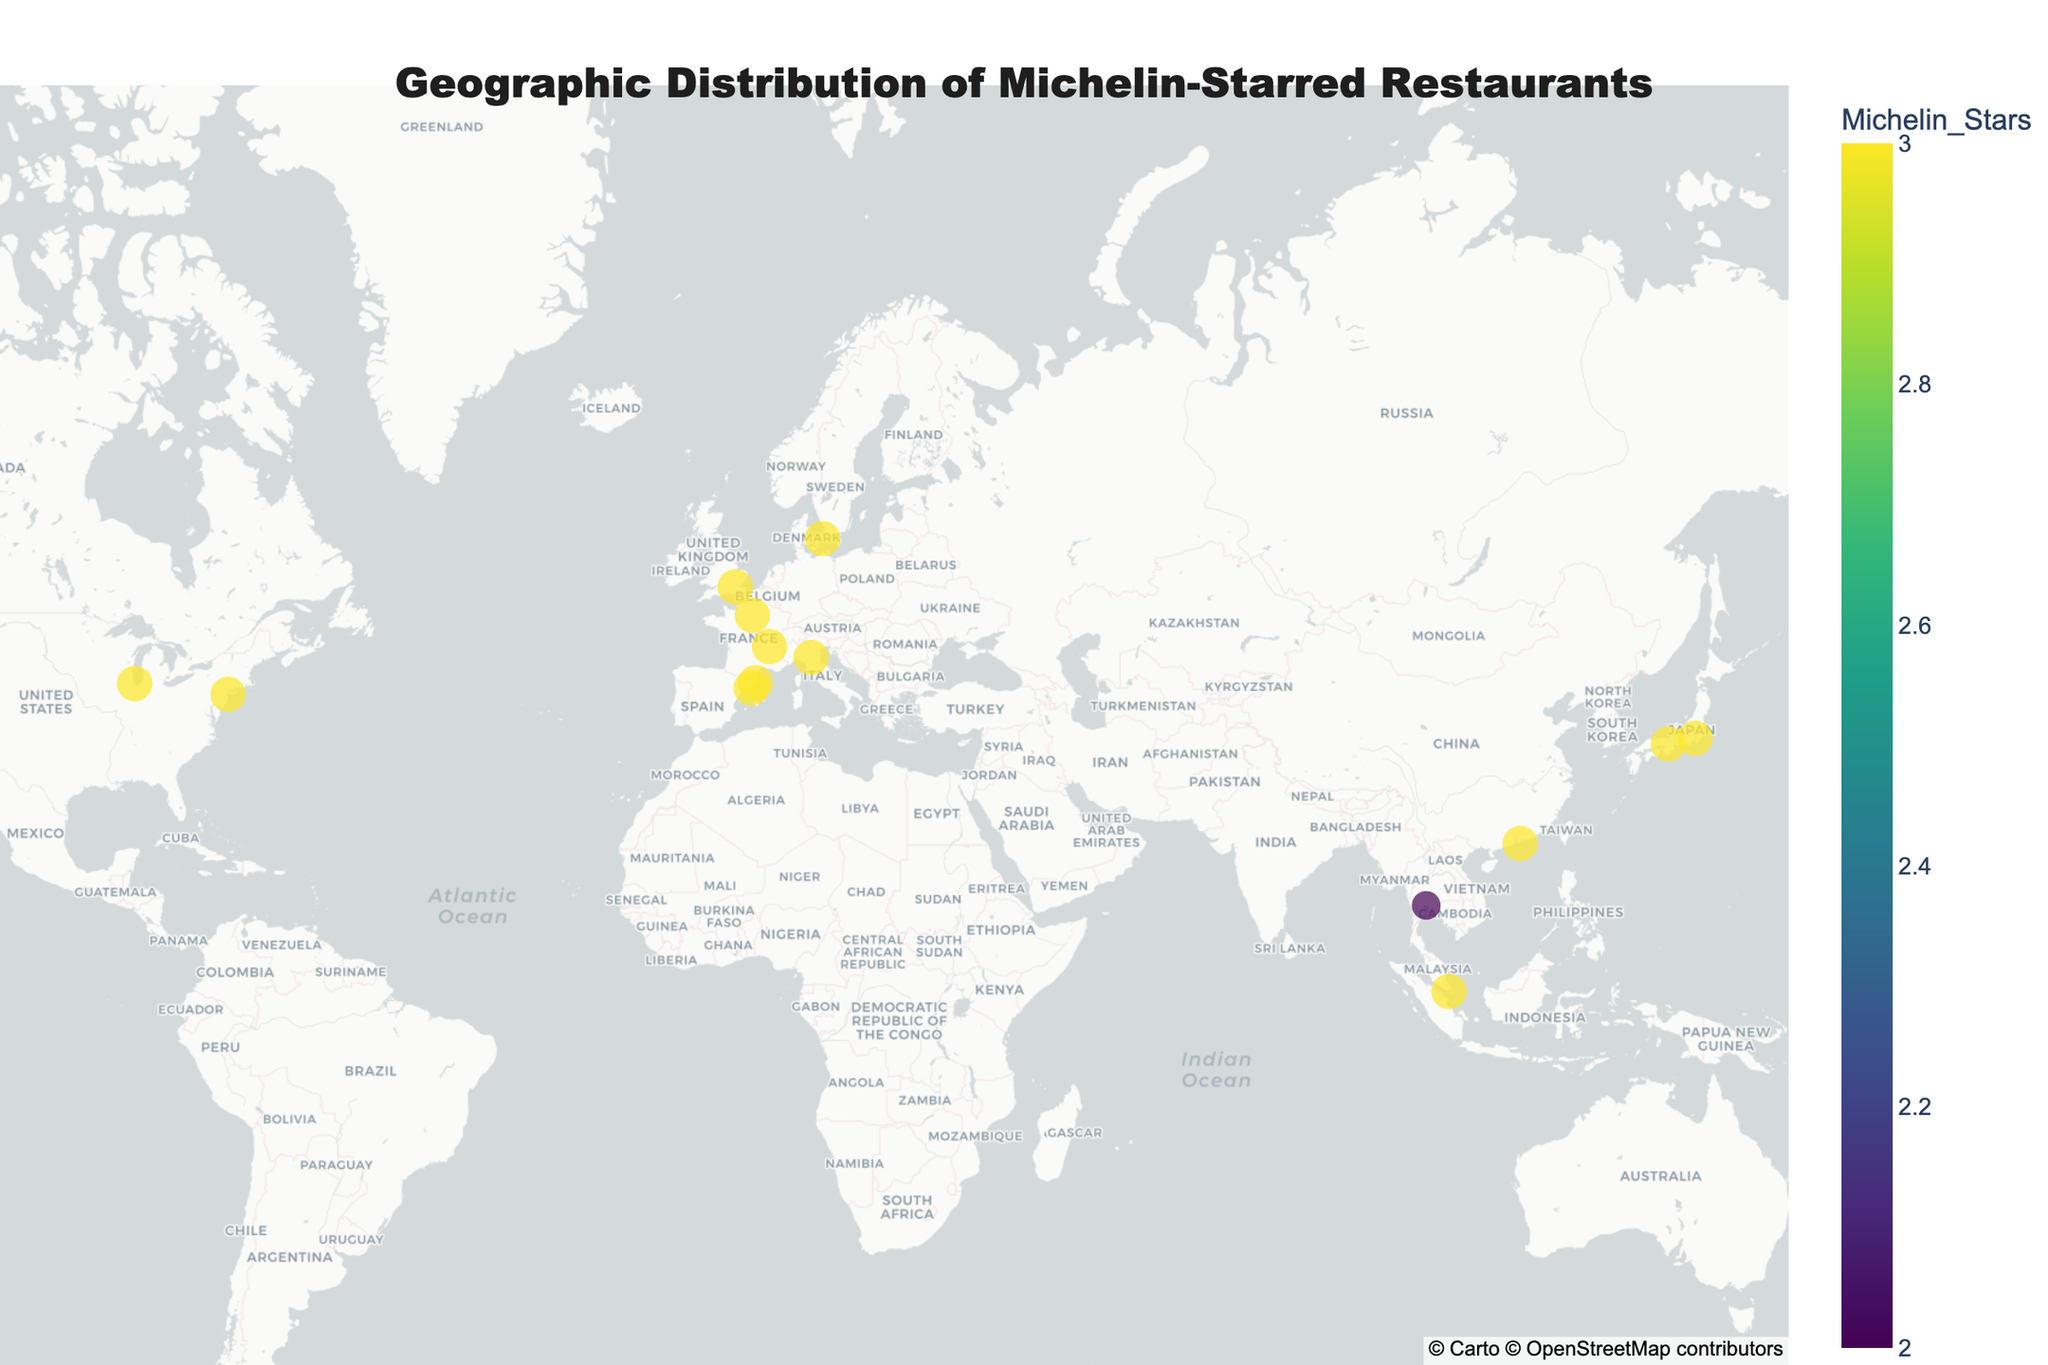What is the title of the map? The title of the map is usually prominently displayed at the top. Reading the top part of the figure will show the title "Geographic Distribution of Michelin-Starred Restaurants".
Answer: Geographic Distribution of Michelin-Starred Restaurants How many restaurants are located in the United States? Observing the map and identifying the points in the United States shows restaurants in New York City, San Francisco, and Chicago. Counting these, we get three restaurants.
Answer: 3 Which city has the highest concentration of Michelin-starred restaurants? By looking at the size of the markers on the map and noting the city names, we can see Tokyo, Japan has a 3-star restaurant, which accrues the highest Michelin-starred restaurant concentration represented on the map.
Answer: Tokyo Compare the number of Michelin stars between the restaurants in France. Which city has more? Observing the map points labeled "France," and adding up the Michelin star counts, Paris has 3 stars and Lyon has 3 stars too. Both cities have the same Michelin star count.
Answer: Same How is the Michelin star distribution plotted on the map? The plot uses circles with varying sizes and colors to represent the number of Michelin stars. Larger circles and different colors represent a higher number of Michelin stars at each location.
Answer: Circles with varying sizes and colors How many restaurants with 3 Michelin stars are located in Asia? By identifying and counting the restaurants located in Asian cities (Tokyo, Hong Kong, Kyoto, Singapore) and ensuring they all have 3 stars, we deduce there are four such restaurants.
Answer: 4 Which countries are represented in Europe on this map? Checking each city’s location within Europe, the map includes France, Spain, UK, Denmark, and Italy as the European countries.
Answer: France, Spain, UK, Denmark, Italy Which continent has the least number of 3 Michelin-starred restaurants represented? By counting the number of 3 Michelin-starred restaurants per continent, Africa and South America don't have any restaurants shown but are not part of the dataset, leaving Oceania, which also isn't shown but presumed not to be included, thus Asia and Europe are counted, making North America the least with only two cities.
Answer: North America What is the average latitude of the Michelin-starred restaurants in the United States? Observing the latitudes for the U.S. cities (New York City, San Francisco, Chicago) and averaging them: (40.7128 + 37.7749 + 41.8781)/3 = 40.12
Answer: 40.12 Which two cities are closest in latitude but are in different countries? Observing the latitudes of the cities, London (51.5074) in the UK and Copenhagen (55.6761) in Denmark are the closest.
Answer: London and Copenhagen 